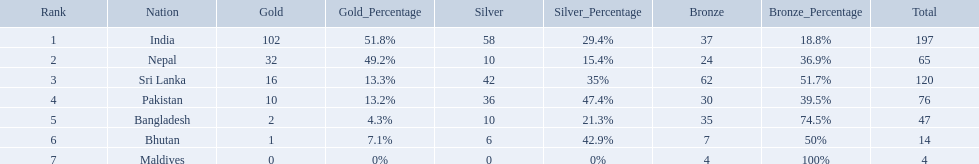What countries attended the 1999 south asian games? India, Nepal, Sri Lanka, Pakistan, Bangladesh, Bhutan, Maldives. Which of these countries had 32 gold medals? Nepal. Could you parse the entire table as a dict? {'header': ['Rank', 'Nation', 'Gold', 'Gold_Percentage', 'Silver', 'Silver_Percentage', 'Bronze', 'Bronze_Percentage', 'Total'], 'rows': [['1', 'India', '102', '51.8%', '58', '29.4%', '37', '18.8%', '197'], ['2', 'Nepal', '32', '49.2%', '10', '15.4%', '24', '36.9%', '65'], ['3', 'Sri Lanka', '16', '13.3%', '42', '35%', '62', '51.7%', '120'], ['4', 'Pakistan', '10', '13.2%', '36', '47.4%', '30', '39.5%', '76'], ['5', 'Bangladesh', '2', '4.3%', '10', '21.3%', '35', '74.5%', '47'], ['6', 'Bhutan', '1', '7.1%', '6', '42.9%', '7', '50%', '14'], ['7', 'Maldives', '0', '0%', '0', '0%', '4', '100%', '4']]} Which nations played at the 1999 south asian games? India, Nepal, Sri Lanka, Pakistan, Bangladesh, Bhutan, Maldives. Which country is listed second in the table? Nepal. What are all the countries listed in the table? India, Nepal, Sri Lanka, Pakistan, Bangladesh, Bhutan, Maldives. Which of these is not india? Nepal, Sri Lanka, Pakistan, Bangladesh, Bhutan, Maldives. Of these, which is first? Nepal. Would you be able to parse every entry in this table? {'header': ['Rank', 'Nation', 'Gold', 'Gold_Percentage', 'Silver', 'Silver_Percentage', 'Bronze', 'Bronze_Percentage', 'Total'], 'rows': [['1', 'India', '102', '51.8%', '58', '29.4%', '37', '18.8%', '197'], ['2', 'Nepal', '32', '49.2%', '10', '15.4%', '24', '36.9%', '65'], ['3', 'Sri Lanka', '16', '13.3%', '42', '35%', '62', '51.7%', '120'], ['4', 'Pakistan', '10', '13.2%', '36', '47.4%', '30', '39.5%', '76'], ['5', 'Bangladesh', '2', '4.3%', '10', '21.3%', '35', '74.5%', '47'], ['6', 'Bhutan', '1', '7.1%', '6', '42.9%', '7', '50%', '14'], ['7', 'Maldives', '0', '0%', '0', '0%', '4', '100%', '4']]} 